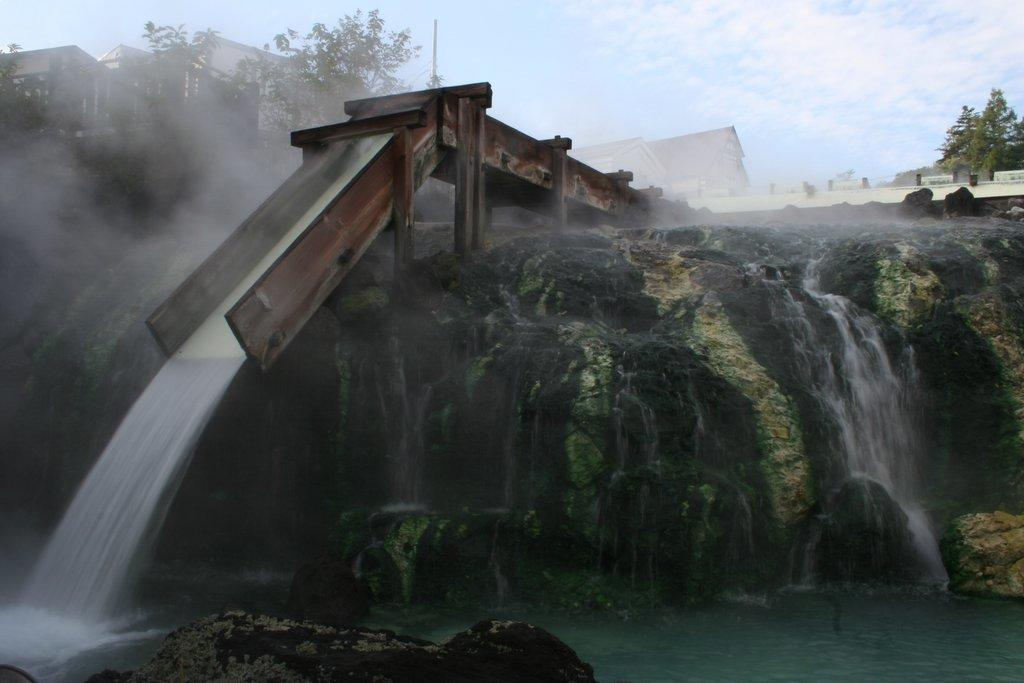What is the primary element in the image? There is water in the image. What other natural feature can be seen in the image? There is a huge rock in the image. What structure is present in the image? There is a wooden bridge in the image. What is happening with the water and the bridge? Water is falling from the bridge. What can be seen in the background of the image? There are trees, buildings, and the sky visible in the background of the image. How many servants are attending to the waterfall in the image? There are no servants present in the image. What type of soap is being used to clean the wooden bridge in the image? There is no soap or cleaning activity depicted in the image. 